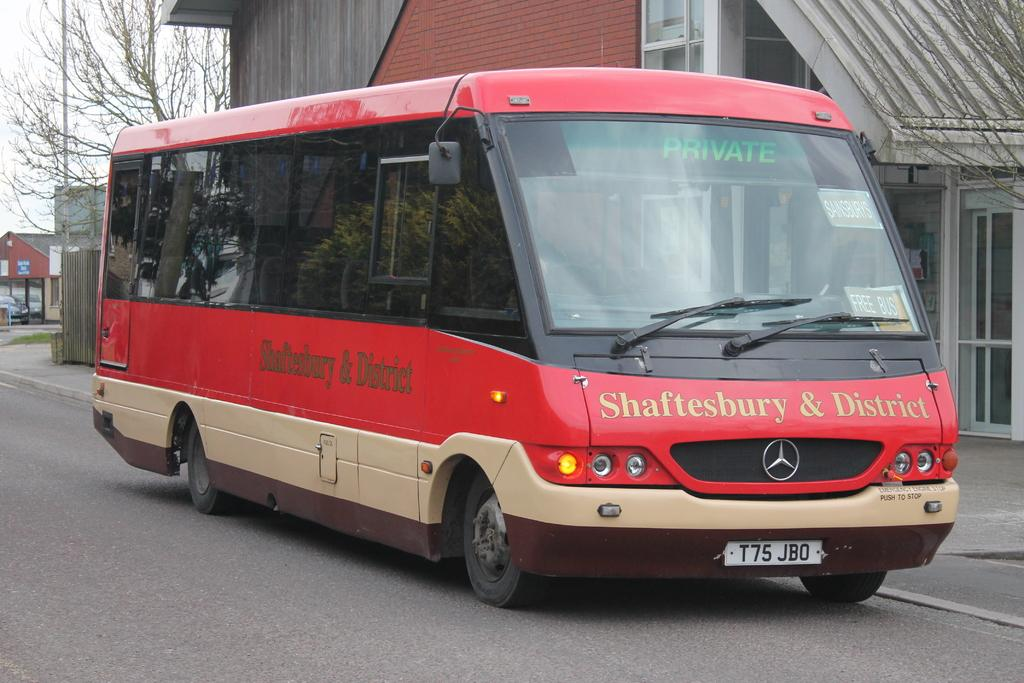What is the main subject in the center of the image? There is a bus in the center of the image. What can be seen in the background of the image? There are houses, trees, a pole, and a car in the background of the image. Can you tell me how many donkeys are pulling the bus in the image? There are no donkeys present in the image; the bus is not being pulled by any animals. What type of war is depicted in the image? There is no war depicted in the image; it features a bus and various background elements. 